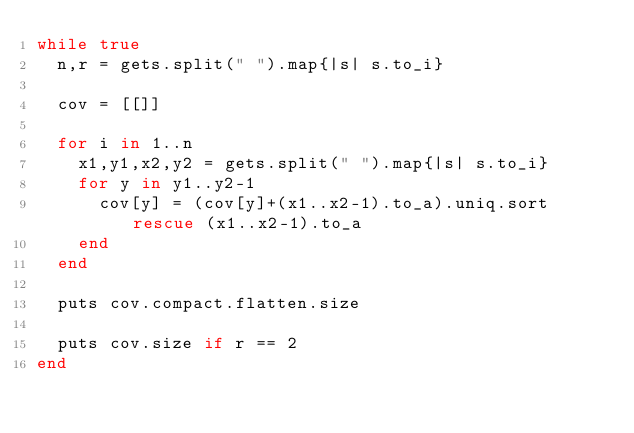Convert code to text. <code><loc_0><loc_0><loc_500><loc_500><_Ruby_>while true
  n,r = gets.split(" ").map{|s| s.to_i}

  cov = [[]]
  
  for i in 1..n
    x1,y1,x2,y2 = gets.split(" ").map{|s| s.to_i}
    for y in y1..y2-1
      cov[y] = (cov[y]+(x1..x2-1).to_a).uniq.sort rescue (x1..x2-1).to_a
    end
  end
 
  puts cov.compact.flatten.size

  puts cov.size if r == 2
end    </code> 